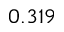Convert formula to latex. <formula><loc_0><loc_0><loc_500><loc_500>0 . 3 1 9</formula> 